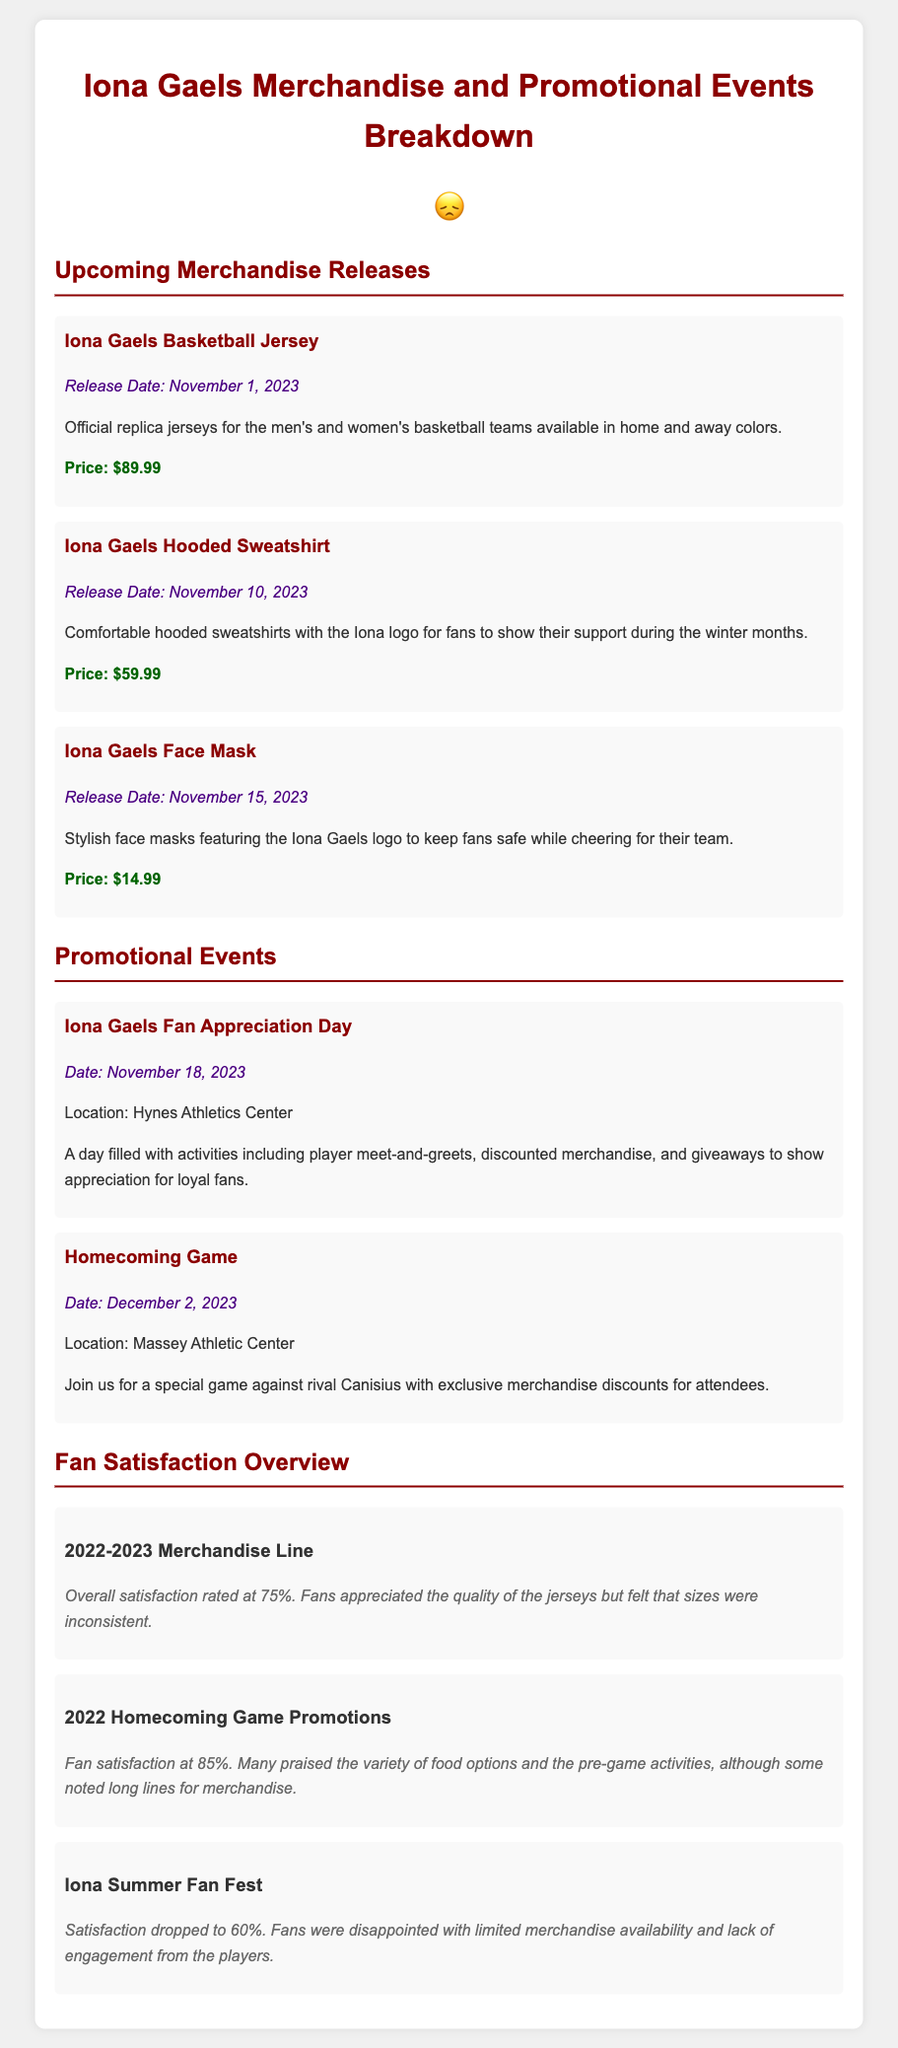what is the release date of the Iona Gaels Basketball Jersey? The release date is mentioned under the merchandise section for the Basketball Jersey.
Answer: November 1, 2023 what is the price of the Iona Gaels Hooded Sweatshirt? The price is provided alongside the description of the Hooded Sweatshirt.
Answer: $59.99 what event is scheduled for November 18, 2023? The event title is listed under the promotional events section with its corresponding date.
Answer: Iona Gaels Fan Appreciation Day how satisfied were fans with the merchandise line in 2022-2023? The satisfaction rating is specified in the Fan Satisfaction Overview section for the 2022-2023 merchandise line.
Answer: 75% which event had a satisfaction rate of 85%? The satisfaction level is noted in the Fan Satisfaction Overview related to a particular event.
Answer: 2022 Homecoming Game Promotions what feedback did fans provide about the Iona Summer Fan Fest? The feedback is summarized in the Fan Satisfaction Overview regarding the Iona Summer Fan Fest experience.
Answer: Limited merchandise availability and lack of engagement from the players how many merchandise items are scheduled to be released in November 2023? The document lists the specific merchandise items along with their release dates.
Answer: Three which location is mentioned for the Homecoming Game? The location is provided along with the details of the event scheduled for December 2, 2023.
Answer: Massey Athletic Center 